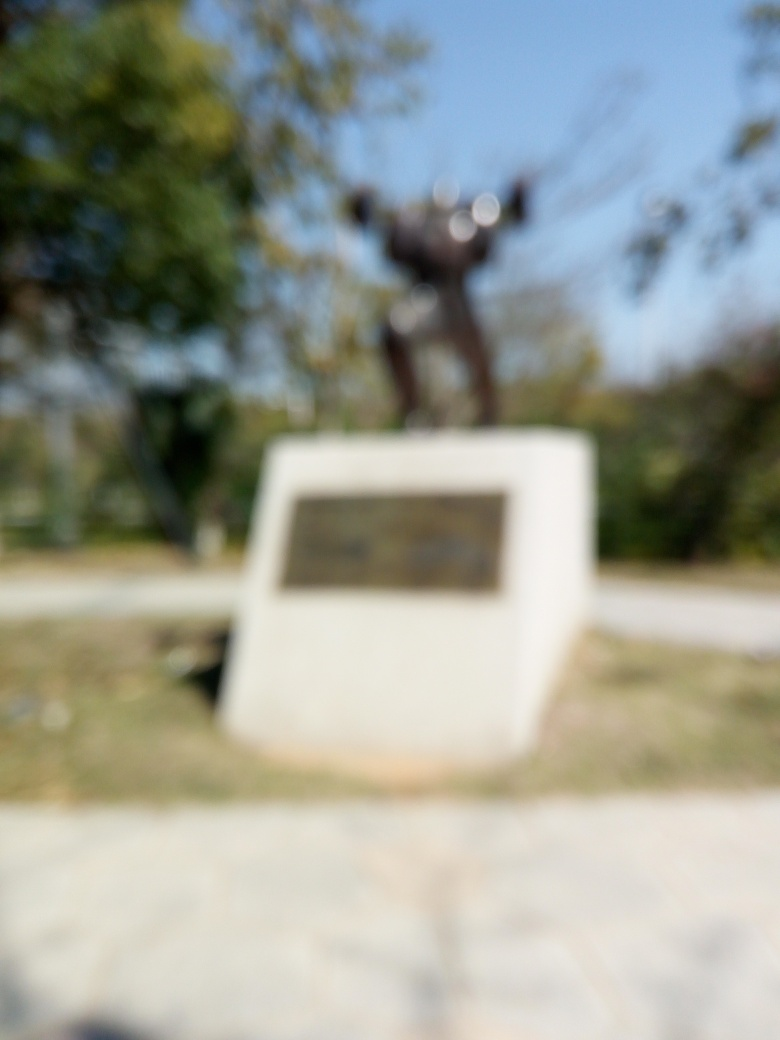What details can you infer from this blurred image? Even though the image is significantly blurred, one can vaguely discern a shape that appears to be a statue, possibly in an outdoor setting with some foliage around it. The specific features, textures, or any inscriptions are indistinguishable due to the poor focus. 